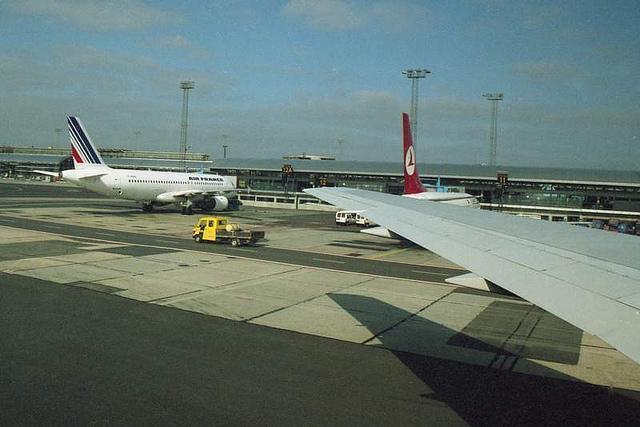What fuel does the plane require?
Choose the right answer from the provided options to respond to the question.
Options: Coal, jetfuel, diesel, electricity. Jetfuel. 